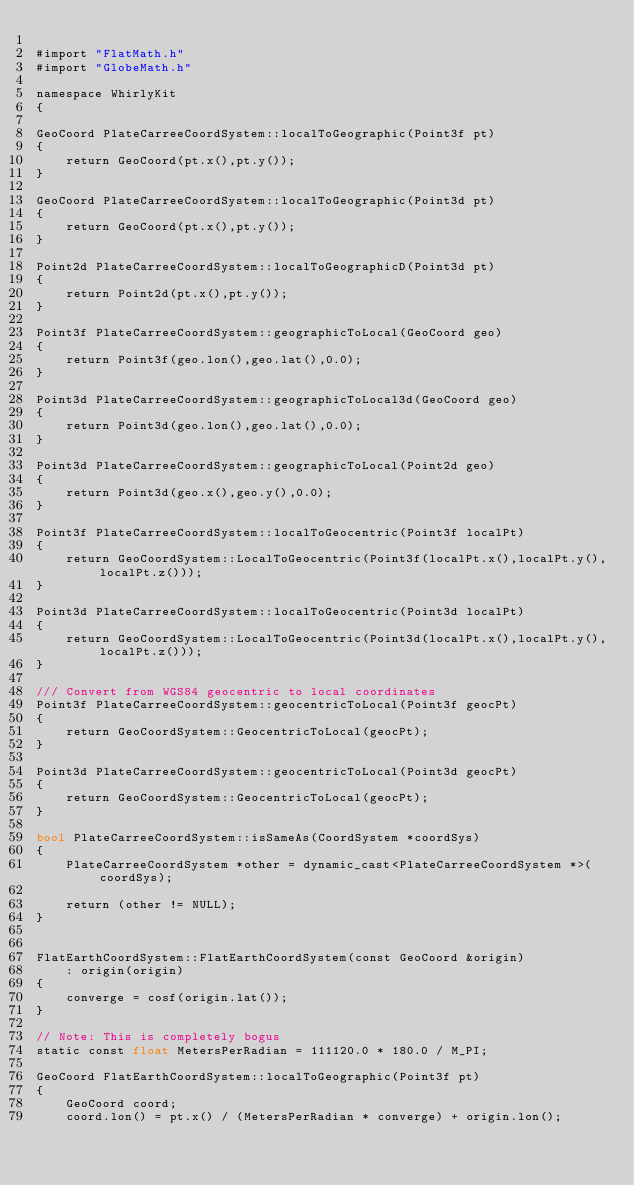Convert code to text. <code><loc_0><loc_0><loc_500><loc_500><_ObjectiveC_>
#import "FlatMath.h"
#import "GlobeMath.h"

namespace WhirlyKit
{
        
GeoCoord PlateCarreeCoordSystem::localToGeographic(Point3f pt)
{
    return GeoCoord(pt.x(),pt.y());
}

GeoCoord PlateCarreeCoordSystem::localToGeographic(Point3d pt)
{
    return GeoCoord(pt.x(),pt.y());
}

Point2d PlateCarreeCoordSystem::localToGeographicD(Point3d pt)
{
    return Point2d(pt.x(),pt.y());
}

Point3f PlateCarreeCoordSystem::geographicToLocal(GeoCoord geo)
{
    return Point3f(geo.lon(),geo.lat(),0.0);
}

Point3d PlateCarreeCoordSystem::geographicToLocal3d(GeoCoord geo)
{
    return Point3d(geo.lon(),geo.lat(),0.0);
}

Point3d PlateCarreeCoordSystem::geographicToLocal(Point2d geo)
{
    return Point3d(geo.x(),geo.y(),0.0);
}

Point3f PlateCarreeCoordSystem::localToGeocentric(Point3f localPt)
{
    return GeoCoordSystem::LocalToGeocentric(Point3f(localPt.x(),localPt.y(),localPt.z()));
}

Point3d PlateCarreeCoordSystem::localToGeocentric(Point3d localPt)
{
    return GeoCoordSystem::LocalToGeocentric(Point3d(localPt.x(),localPt.y(),localPt.z()));
}
    
/// Convert from WGS84 geocentric to local coordinates
Point3f PlateCarreeCoordSystem::geocentricToLocal(Point3f geocPt)
{
    return GeoCoordSystem::GeocentricToLocal(geocPt);
}

Point3d PlateCarreeCoordSystem::geocentricToLocal(Point3d geocPt)
{
    return GeoCoordSystem::GeocentricToLocal(geocPt);
}
    
bool PlateCarreeCoordSystem::isSameAs(CoordSystem *coordSys)
{
    PlateCarreeCoordSystem *other = dynamic_cast<PlateCarreeCoordSystem *>(coordSys);
    
    return (other != NULL);
}

        
FlatEarthCoordSystem::FlatEarthCoordSystem(const GeoCoord &origin)
    : origin(origin)
{
    converge = cosf(origin.lat());    
}
    
// Note: This is completely bogus
static const float MetersPerRadian = 111120.0 * 180.0 / M_PI;

GeoCoord FlatEarthCoordSystem::localToGeographic(Point3f pt)
{
    GeoCoord coord;
    coord.lon() = pt.x() / (MetersPerRadian * converge) + origin.lon();</code> 